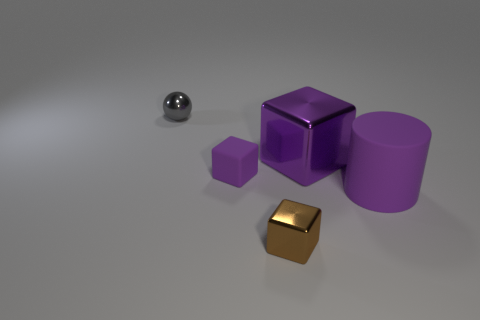There is a gray object; is its shape the same as the rubber thing that is behind the large matte cylinder?
Make the answer very short. No. The large rubber object that is the same color as the big metal cube is what shape?
Give a very brief answer. Cylinder. Is the number of cubes that are to the left of the tiny brown object less than the number of blocks?
Give a very brief answer. Yes. Is the shape of the big purple rubber thing the same as the gray shiny thing?
Provide a short and direct response. No. What is the size of the purple cube that is the same material as the tiny gray thing?
Keep it short and to the point. Large. Are there fewer purple matte things than big purple shiny things?
Give a very brief answer. No. What number of big objects are either purple rubber balls or gray objects?
Ensure brevity in your answer.  0. What number of purple things are to the right of the small brown shiny cube and in front of the big block?
Keep it short and to the point. 1. Are there more cylinders than tiny yellow rubber cylinders?
Your response must be concise. Yes. What number of other objects are the same shape as the large purple shiny object?
Your answer should be compact. 2. 